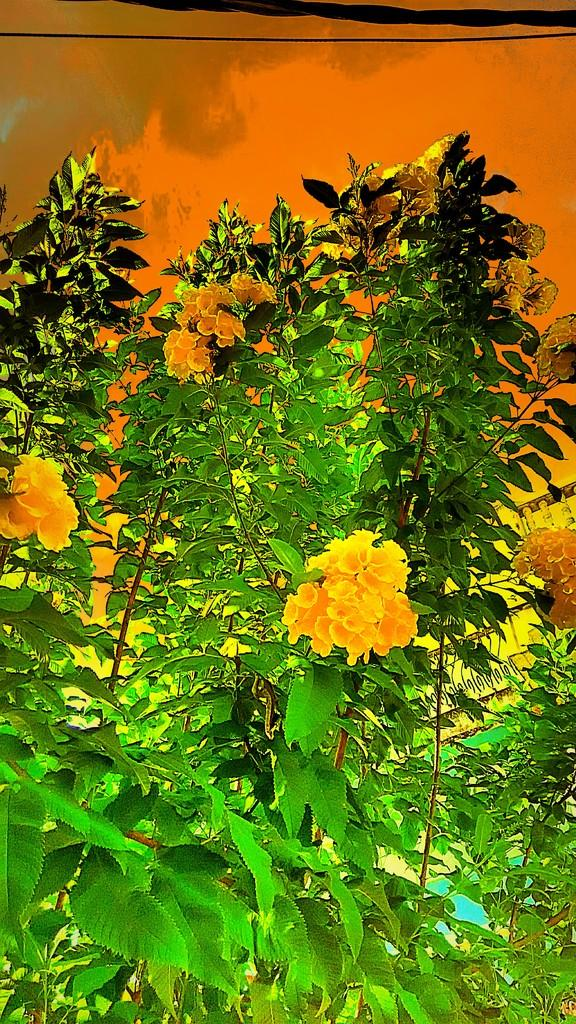What type of plants can be seen in the image? There are plants with flowers in the image. What is visible in the background of the image? There is a wall in the background of the image. What type of arm is visible in the image? There is no arm present in the image; it features plants with flowers and a wall in the background. 